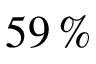<formula> <loc_0><loc_0><loc_500><loc_500>5 9 \, \%</formula> 